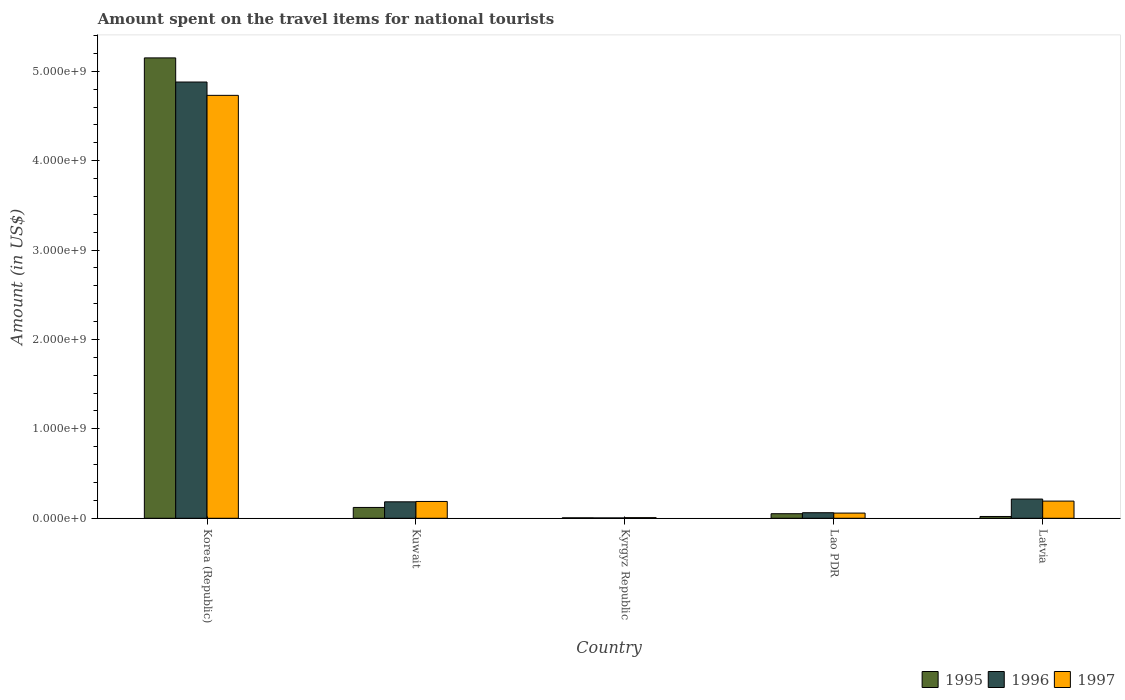How many different coloured bars are there?
Make the answer very short. 3. Are the number of bars on each tick of the X-axis equal?
Ensure brevity in your answer.  Yes. How many bars are there on the 1st tick from the left?
Offer a very short reply. 3. How many bars are there on the 1st tick from the right?
Offer a terse response. 3. What is the label of the 1st group of bars from the left?
Your answer should be compact. Korea (Republic). What is the amount spent on the travel items for national tourists in 1996 in Kuwait?
Provide a short and direct response. 1.84e+08. Across all countries, what is the maximum amount spent on the travel items for national tourists in 1997?
Make the answer very short. 4.73e+09. Across all countries, what is the minimum amount spent on the travel items for national tourists in 1996?
Your answer should be very brief. 4.00e+06. In which country was the amount spent on the travel items for national tourists in 1996 minimum?
Provide a succinct answer. Kyrgyz Republic. What is the total amount spent on the travel items for national tourists in 1996 in the graph?
Make the answer very short. 5.34e+09. What is the difference between the amount spent on the travel items for national tourists in 1995 in Korea (Republic) and that in Kyrgyz Republic?
Your answer should be compact. 5.14e+09. What is the difference between the amount spent on the travel items for national tourists in 1995 in Lao PDR and the amount spent on the travel items for national tourists in 1997 in Kyrgyz Republic?
Your answer should be compact. 4.40e+07. What is the average amount spent on the travel items for national tourists in 1995 per country?
Your answer should be very brief. 1.07e+09. What is the difference between the amount spent on the travel items for national tourists of/in 1997 and amount spent on the travel items for national tourists of/in 1996 in Latvia?
Keep it short and to the point. -2.30e+07. In how many countries, is the amount spent on the travel items for national tourists in 1996 greater than 1200000000 US$?
Offer a very short reply. 1. What is the ratio of the amount spent on the travel items for national tourists in 1997 in Kuwait to that in Latvia?
Provide a succinct answer. 0.98. Is the difference between the amount spent on the travel items for national tourists in 1997 in Korea (Republic) and Kyrgyz Republic greater than the difference between the amount spent on the travel items for national tourists in 1996 in Korea (Republic) and Kyrgyz Republic?
Provide a succinct answer. No. What is the difference between the highest and the second highest amount spent on the travel items for national tourists in 1995?
Ensure brevity in your answer.  5.03e+09. What is the difference between the highest and the lowest amount spent on the travel items for national tourists in 1997?
Ensure brevity in your answer.  4.72e+09. What does the 3rd bar from the left in Kuwait represents?
Ensure brevity in your answer.  1997. Are all the bars in the graph horizontal?
Make the answer very short. No. How many countries are there in the graph?
Offer a terse response. 5. What is the difference between two consecutive major ticks on the Y-axis?
Your response must be concise. 1.00e+09. Does the graph contain grids?
Offer a very short reply. No. Where does the legend appear in the graph?
Offer a terse response. Bottom right. How are the legend labels stacked?
Keep it short and to the point. Horizontal. What is the title of the graph?
Provide a succinct answer. Amount spent on the travel items for national tourists. What is the label or title of the X-axis?
Your response must be concise. Country. What is the Amount (in US$) in 1995 in Korea (Republic)?
Provide a short and direct response. 5.15e+09. What is the Amount (in US$) in 1996 in Korea (Republic)?
Offer a terse response. 4.88e+09. What is the Amount (in US$) of 1997 in Korea (Republic)?
Keep it short and to the point. 4.73e+09. What is the Amount (in US$) in 1995 in Kuwait?
Your answer should be compact. 1.21e+08. What is the Amount (in US$) in 1996 in Kuwait?
Provide a short and direct response. 1.84e+08. What is the Amount (in US$) in 1997 in Kuwait?
Offer a terse response. 1.88e+08. What is the Amount (in US$) of 1995 in Lao PDR?
Give a very brief answer. 5.10e+07. What is the Amount (in US$) in 1996 in Lao PDR?
Offer a terse response. 6.20e+07. What is the Amount (in US$) in 1997 in Lao PDR?
Offer a terse response. 5.80e+07. What is the Amount (in US$) of 1995 in Latvia?
Make the answer very short. 2.00e+07. What is the Amount (in US$) in 1996 in Latvia?
Provide a succinct answer. 2.15e+08. What is the Amount (in US$) in 1997 in Latvia?
Provide a succinct answer. 1.92e+08. Across all countries, what is the maximum Amount (in US$) in 1995?
Keep it short and to the point. 5.15e+09. Across all countries, what is the maximum Amount (in US$) in 1996?
Your response must be concise. 4.88e+09. Across all countries, what is the maximum Amount (in US$) of 1997?
Your answer should be compact. 4.73e+09. Across all countries, what is the minimum Amount (in US$) in 1996?
Give a very brief answer. 4.00e+06. Across all countries, what is the minimum Amount (in US$) in 1997?
Offer a terse response. 7.00e+06. What is the total Amount (in US$) of 1995 in the graph?
Your response must be concise. 5.35e+09. What is the total Amount (in US$) in 1996 in the graph?
Your response must be concise. 5.34e+09. What is the total Amount (in US$) in 1997 in the graph?
Ensure brevity in your answer.  5.18e+09. What is the difference between the Amount (in US$) of 1995 in Korea (Republic) and that in Kuwait?
Make the answer very short. 5.03e+09. What is the difference between the Amount (in US$) in 1996 in Korea (Republic) and that in Kuwait?
Keep it short and to the point. 4.70e+09. What is the difference between the Amount (in US$) in 1997 in Korea (Republic) and that in Kuwait?
Provide a short and direct response. 4.54e+09. What is the difference between the Amount (in US$) of 1995 in Korea (Republic) and that in Kyrgyz Republic?
Provide a short and direct response. 5.14e+09. What is the difference between the Amount (in US$) in 1996 in Korea (Republic) and that in Kyrgyz Republic?
Your answer should be very brief. 4.88e+09. What is the difference between the Amount (in US$) in 1997 in Korea (Republic) and that in Kyrgyz Republic?
Your answer should be very brief. 4.72e+09. What is the difference between the Amount (in US$) of 1995 in Korea (Republic) and that in Lao PDR?
Provide a succinct answer. 5.10e+09. What is the difference between the Amount (in US$) of 1996 in Korea (Republic) and that in Lao PDR?
Give a very brief answer. 4.82e+09. What is the difference between the Amount (in US$) in 1997 in Korea (Republic) and that in Lao PDR?
Your response must be concise. 4.67e+09. What is the difference between the Amount (in US$) in 1995 in Korea (Republic) and that in Latvia?
Provide a succinct answer. 5.13e+09. What is the difference between the Amount (in US$) of 1996 in Korea (Republic) and that in Latvia?
Make the answer very short. 4.66e+09. What is the difference between the Amount (in US$) in 1997 in Korea (Republic) and that in Latvia?
Offer a terse response. 4.54e+09. What is the difference between the Amount (in US$) in 1995 in Kuwait and that in Kyrgyz Republic?
Offer a very short reply. 1.16e+08. What is the difference between the Amount (in US$) in 1996 in Kuwait and that in Kyrgyz Republic?
Offer a very short reply. 1.80e+08. What is the difference between the Amount (in US$) in 1997 in Kuwait and that in Kyrgyz Republic?
Your answer should be compact. 1.81e+08. What is the difference between the Amount (in US$) of 1995 in Kuwait and that in Lao PDR?
Keep it short and to the point. 7.00e+07. What is the difference between the Amount (in US$) in 1996 in Kuwait and that in Lao PDR?
Your response must be concise. 1.22e+08. What is the difference between the Amount (in US$) in 1997 in Kuwait and that in Lao PDR?
Offer a terse response. 1.30e+08. What is the difference between the Amount (in US$) in 1995 in Kuwait and that in Latvia?
Provide a succinct answer. 1.01e+08. What is the difference between the Amount (in US$) of 1996 in Kuwait and that in Latvia?
Offer a terse response. -3.10e+07. What is the difference between the Amount (in US$) in 1997 in Kuwait and that in Latvia?
Your answer should be very brief. -4.00e+06. What is the difference between the Amount (in US$) of 1995 in Kyrgyz Republic and that in Lao PDR?
Your answer should be compact. -4.60e+07. What is the difference between the Amount (in US$) of 1996 in Kyrgyz Republic and that in Lao PDR?
Ensure brevity in your answer.  -5.80e+07. What is the difference between the Amount (in US$) of 1997 in Kyrgyz Republic and that in Lao PDR?
Your answer should be very brief. -5.10e+07. What is the difference between the Amount (in US$) in 1995 in Kyrgyz Republic and that in Latvia?
Make the answer very short. -1.50e+07. What is the difference between the Amount (in US$) of 1996 in Kyrgyz Republic and that in Latvia?
Your response must be concise. -2.11e+08. What is the difference between the Amount (in US$) of 1997 in Kyrgyz Republic and that in Latvia?
Your response must be concise. -1.85e+08. What is the difference between the Amount (in US$) of 1995 in Lao PDR and that in Latvia?
Provide a short and direct response. 3.10e+07. What is the difference between the Amount (in US$) in 1996 in Lao PDR and that in Latvia?
Provide a succinct answer. -1.53e+08. What is the difference between the Amount (in US$) in 1997 in Lao PDR and that in Latvia?
Ensure brevity in your answer.  -1.34e+08. What is the difference between the Amount (in US$) of 1995 in Korea (Republic) and the Amount (in US$) of 1996 in Kuwait?
Offer a terse response. 4.97e+09. What is the difference between the Amount (in US$) of 1995 in Korea (Republic) and the Amount (in US$) of 1997 in Kuwait?
Make the answer very short. 4.96e+09. What is the difference between the Amount (in US$) of 1996 in Korea (Republic) and the Amount (in US$) of 1997 in Kuwait?
Your response must be concise. 4.69e+09. What is the difference between the Amount (in US$) of 1995 in Korea (Republic) and the Amount (in US$) of 1996 in Kyrgyz Republic?
Your answer should be compact. 5.15e+09. What is the difference between the Amount (in US$) of 1995 in Korea (Republic) and the Amount (in US$) of 1997 in Kyrgyz Republic?
Make the answer very short. 5.14e+09. What is the difference between the Amount (in US$) in 1996 in Korea (Republic) and the Amount (in US$) in 1997 in Kyrgyz Republic?
Give a very brief answer. 4.87e+09. What is the difference between the Amount (in US$) of 1995 in Korea (Republic) and the Amount (in US$) of 1996 in Lao PDR?
Make the answer very short. 5.09e+09. What is the difference between the Amount (in US$) in 1995 in Korea (Republic) and the Amount (in US$) in 1997 in Lao PDR?
Give a very brief answer. 5.09e+09. What is the difference between the Amount (in US$) in 1996 in Korea (Republic) and the Amount (in US$) in 1997 in Lao PDR?
Offer a terse response. 4.82e+09. What is the difference between the Amount (in US$) of 1995 in Korea (Republic) and the Amount (in US$) of 1996 in Latvia?
Make the answer very short. 4.94e+09. What is the difference between the Amount (in US$) of 1995 in Korea (Republic) and the Amount (in US$) of 1997 in Latvia?
Offer a very short reply. 4.96e+09. What is the difference between the Amount (in US$) of 1996 in Korea (Republic) and the Amount (in US$) of 1997 in Latvia?
Provide a short and direct response. 4.69e+09. What is the difference between the Amount (in US$) in 1995 in Kuwait and the Amount (in US$) in 1996 in Kyrgyz Republic?
Offer a very short reply. 1.17e+08. What is the difference between the Amount (in US$) in 1995 in Kuwait and the Amount (in US$) in 1997 in Kyrgyz Republic?
Make the answer very short. 1.14e+08. What is the difference between the Amount (in US$) in 1996 in Kuwait and the Amount (in US$) in 1997 in Kyrgyz Republic?
Your answer should be compact. 1.77e+08. What is the difference between the Amount (in US$) in 1995 in Kuwait and the Amount (in US$) in 1996 in Lao PDR?
Offer a terse response. 5.90e+07. What is the difference between the Amount (in US$) of 1995 in Kuwait and the Amount (in US$) of 1997 in Lao PDR?
Provide a short and direct response. 6.30e+07. What is the difference between the Amount (in US$) of 1996 in Kuwait and the Amount (in US$) of 1997 in Lao PDR?
Ensure brevity in your answer.  1.26e+08. What is the difference between the Amount (in US$) in 1995 in Kuwait and the Amount (in US$) in 1996 in Latvia?
Your response must be concise. -9.40e+07. What is the difference between the Amount (in US$) of 1995 in Kuwait and the Amount (in US$) of 1997 in Latvia?
Make the answer very short. -7.10e+07. What is the difference between the Amount (in US$) of 1996 in Kuwait and the Amount (in US$) of 1997 in Latvia?
Ensure brevity in your answer.  -8.00e+06. What is the difference between the Amount (in US$) of 1995 in Kyrgyz Republic and the Amount (in US$) of 1996 in Lao PDR?
Make the answer very short. -5.70e+07. What is the difference between the Amount (in US$) in 1995 in Kyrgyz Republic and the Amount (in US$) in 1997 in Lao PDR?
Your response must be concise. -5.30e+07. What is the difference between the Amount (in US$) of 1996 in Kyrgyz Republic and the Amount (in US$) of 1997 in Lao PDR?
Your answer should be compact. -5.40e+07. What is the difference between the Amount (in US$) of 1995 in Kyrgyz Republic and the Amount (in US$) of 1996 in Latvia?
Give a very brief answer. -2.10e+08. What is the difference between the Amount (in US$) of 1995 in Kyrgyz Republic and the Amount (in US$) of 1997 in Latvia?
Keep it short and to the point. -1.87e+08. What is the difference between the Amount (in US$) of 1996 in Kyrgyz Republic and the Amount (in US$) of 1997 in Latvia?
Provide a succinct answer. -1.88e+08. What is the difference between the Amount (in US$) in 1995 in Lao PDR and the Amount (in US$) in 1996 in Latvia?
Offer a terse response. -1.64e+08. What is the difference between the Amount (in US$) in 1995 in Lao PDR and the Amount (in US$) in 1997 in Latvia?
Your response must be concise. -1.41e+08. What is the difference between the Amount (in US$) of 1996 in Lao PDR and the Amount (in US$) of 1997 in Latvia?
Provide a succinct answer. -1.30e+08. What is the average Amount (in US$) of 1995 per country?
Ensure brevity in your answer.  1.07e+09. What is the average Amount (in US$) of 1996 per country?
Your answer should be compact. 1.07e+09. What is the average Amount (in US$) of 1997 per country?
Your answer should be very brief. 1.04e+09. What is the difference between the Amount (in US$) of 1995 and Amount (in US$) of 1996 in Korea (Republic)?
Give a very brief answer. 2.70e+08. What is the difference between the Amount (in US$) in 1995 and Amount (in US$) in 1997 in Korea (Republic)?
Provide a succinct answer. 4.19e+08. What is the difference between the Amount (in US$) of 1996 and Amount (in US$) of 1997 in Korea (Republic)?
Your response must be concise. 1.49e+08. What is the difference between the Amount (in US$) of 1995 and Amount (in US$) of 1996 in Kuwait?
Offer a terse response. -6.30e+07. What is the difference between the Amount (in US$) in 1995 and Amount (in US$) in 1997 in Kuwait?
Your answer should be very brief. -6.70e+07. What is the difference between the Amount (in US$) in 1995 and Amount (in US$) in 1997 in Kyrgyz Republic?
Give a very brief answer. -2.00e+06. What is the difference between the Amount (in US$) of 1995 and Amount (in US$) of 1996 in Lao PDR?
Provide a succinct answer. -1.10e+07. What is the difference between the Amount (in US$) of 1995 and Amount (in US$) of 1997 in Lao PDR?
Make the answer very short. -7.00e+06. What is the difference between the Amount (in US$) of 1995 and Amount (in US$) of 1996 in Latvia?
Give a very brief answer. -1.95e+08. What is the difference between the Amount (in US$) of 1995 and Amount (in US$) of 1997 in Latvia?
Provide a short and direct response. -1.72e+08. What is the difference between the Amount (in US$) of 1996 and Amount (in US$) of 1997 in Latvia?
Provide a succinct answer. 2.30e+07. What is the ratio of the Amount (in US$) in 1995 in Korea (Republic) to that in Kuwait?
Your answer should be very brief. 42.56. What is the ratio of the Amount (in US$) of 1996 in Korea (Republic) to that in Kuwait?
Offer a very short reply. 26.52. What is the ratio of the Amount (in US$) of 1997 in Korea (Republic) to that in Kuwait?
Make the answer very short. 25.16. What is the ratio of the Amount (in US$) in 1995 in Korea (Republic) to that in Kyrgyz Republic?
Give a very brief answer. 1030. What is the ratio of the Amount (in US$) of 1996 in Korea (Republic) to that in Kyrgyz Republic?
Offer a terse response. 1220. What is the ratio of the Amount (in US$) of 1997 in Korea (Republic) to that in Kyrgyz Republic?
Offer a terse response. 675.86. What is the ratio of the Amount (in US$) of 1995 in Korea (Republic) to that in Lao PDR?
Ensure brevity in your answer.  100.98. What is the ratio of the Amount (in US$) of 1996 in Korea (Republic) to that in Lao PDR?
Provide a succinct answer. 78.71. What is the ratio of the Amount (in US$) of 1997 in Korea (Republic) to that in Lao PDR?
Provide a short and direct response. 81.57. What is the ratio of the Amount (in US$) of 1995 in Korea (Republic) to that in Latvia?
Your answer should be compact. 257.5. What is the ratio of the Amount (in US$) of 1996 in Korea (Republic) to that in Latvia?
Provide a succinct answer. 22.7. What is the ratio of the Amount (in US$) in 1997 in Korea (Republic) to that in Latvia?
Offer a very short reply. 24.64. What is the ratio of the Amount (in US$) in 1995 in Kuwait to that in Kyrgyz Republic?
Your answer should be compact. 24.2. What is the ratio of the Amount (in US$) of 1997 in Kuwait to that in Kyrgyz Republic?
Make the answer very short. 26.86. What is the ratio of the Amount (in US$) of 1995 in Kuwait to that in Lao PDR?
Keep it short and to the point. 2.37. What is the ratio of the Amount (in US$) in 1996 in Kuwait to that in Lao PDR?
Your response must be concise. 2.97. What is the ratio of the Amount (in US$) in 1997 in Kuwait to that in Lao PDR?
Keep it short and to the point. 3.24. What is the ratio of the Amount (in US$) of 1995 in Kuwait to that in Latvia?
Keep it short and to the point. 6.05. What is the ratio of the Amount (in US$) in 1996 in Kuwait to that in Latvia?
Your answer should be compact. 0.86. What is the ratio of the Amount (in US$) of 1997 in Kuwait to that in Latvia?
Make the answer very short. 0.98. What is the ratio of the Amount (in US$) in 1995 in Kyrgyz Republic to that in Lao PDR?
Provide a succinct answer. 0.1. What is the ratio of the Amount (in US$) of 1996 in Kyrgyz Republic to that in Lao PDR?
Your answer should be compact. 0.06. What is the ratio of the Amount (in US$) in 1997 in Kyrgyz Republic to that in Lao PDR?
Your answer should be compact. 0.12. What is the ratio of the Amount (in US$) of 1995 in Kyrgyz Republic to that in Latvia?
Provide a short and direct response. 0.25. What is the ratio of the Amount (in US$) of 1996 in Kyrgyz Republic to that in Latvia?
Keep it short and to the point. 0.02. What is the ratio of the Amount (in US$) in 1997 in Kyrgyz Republic to that in Latvia?
Your response must be concise. 0.04. What is the ratio of the Amount (in US$) in 1995 in Lao PDR to that in Latvia?
Your answer should be very brief. 2.55. What is the ratio of the Amount (in US$) in 1996 in Lao PDR to that in Latvia?
Provide a short and direct response. 0.29. What is the ratio of the Amount (in US$) of 1997 in Lao PDR to that in Latvia?
Your response must be concise. 0.3. What is the difference between the highest and the second highest Amount (in US$) in 1995?
Your answer should be very brief. 5.03e+09. What is the difference between the highest and the second highest Amount (in US$) of 1996?
Your response must be concise. 4.66e+09. What is the difference between the highest and the second highest Amount (in US$) of 1997?
Make the answer very short. 4.54e+09. What is the difference between the highest and the lowest Amount (in US$) of 1995?
Keep it short and to the point. 5.14e+09. What is the difference between the highest and the lowest Amount (in US$) in 1996?
Give a very brief answer. 4.88e+09. What is the difference between the highest and the lowest Amount (in US$) of 1997?
Offer a terse response. 4.72e+09. 